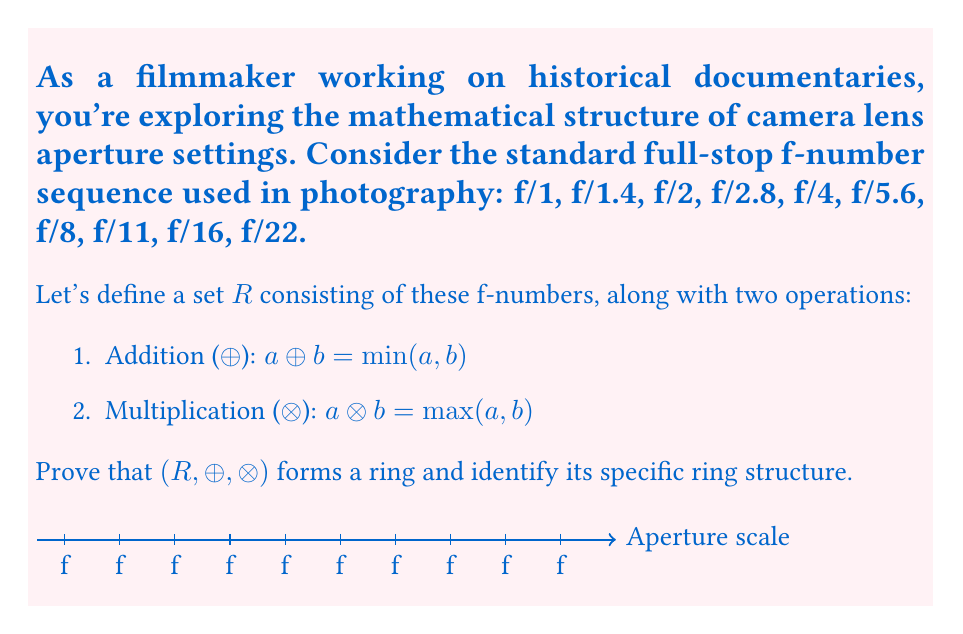Teach me how to tackle this problem. To prove that $(R, \oplus, \otimes)$ forms a ring and identify its structure, we need to verify the ring axioms and analyze its properties:

1. Closure: Both operations are closed in $R$, as $\min$ and $\max$ of any two elements in $R$ are in $R$.

2. Associativity: Both $\oplus$ and $\otimes$ are associative, as $\min$ and $\max$ are associative operations.

3. Commutativity: Both operations are commutative, as $\min(a,b) = \min(b,a)$ and $\max(a,b) = \max(b,a)$.

4. Identity elements: 
   - For $\oplus$: f/22 is the identity, as $\min(x, \text{f/22}) = x$ for all $x \in R$.
   - For $\otimes$: f/1 is the identity, as $\max(x, \text{f/1}) = x$ for all $x \in R$.

5. Inverse elements: Every element is its own inverse under $\oplus$, as $\min(x,x) = x$.

6. Distributivity: $a \otimes (b \oplus c) = \max(a, \min(b,c)) = \min(\max(a,b), \max(a,c)) = (a \otimes b) \oplus (a \otimes c)$

These properties confirm that $(R, \oplus, \otimes)$ is indeed a ring.

Analyzing the structure:
- The ring is commutative.
- It has no zero divisors, as $\max(a,b) = \text{f/22}$ only if $a = b = \text{f/22}$.
- It's idempotent: $a \oplus a = a$ and $a \otimes a = a$ for all $a \in R$.

These properties characterize $(R, \oplus, \otimes)$ as a bounded distributive lattice, specifically a chain lattice due to the total ordering of f-numbers.

In ring theory, this structure is known as a chain ring or a totally ordered idempotent semiring.
Answer: Chain ring (Totally ordered idempotent semiring) 